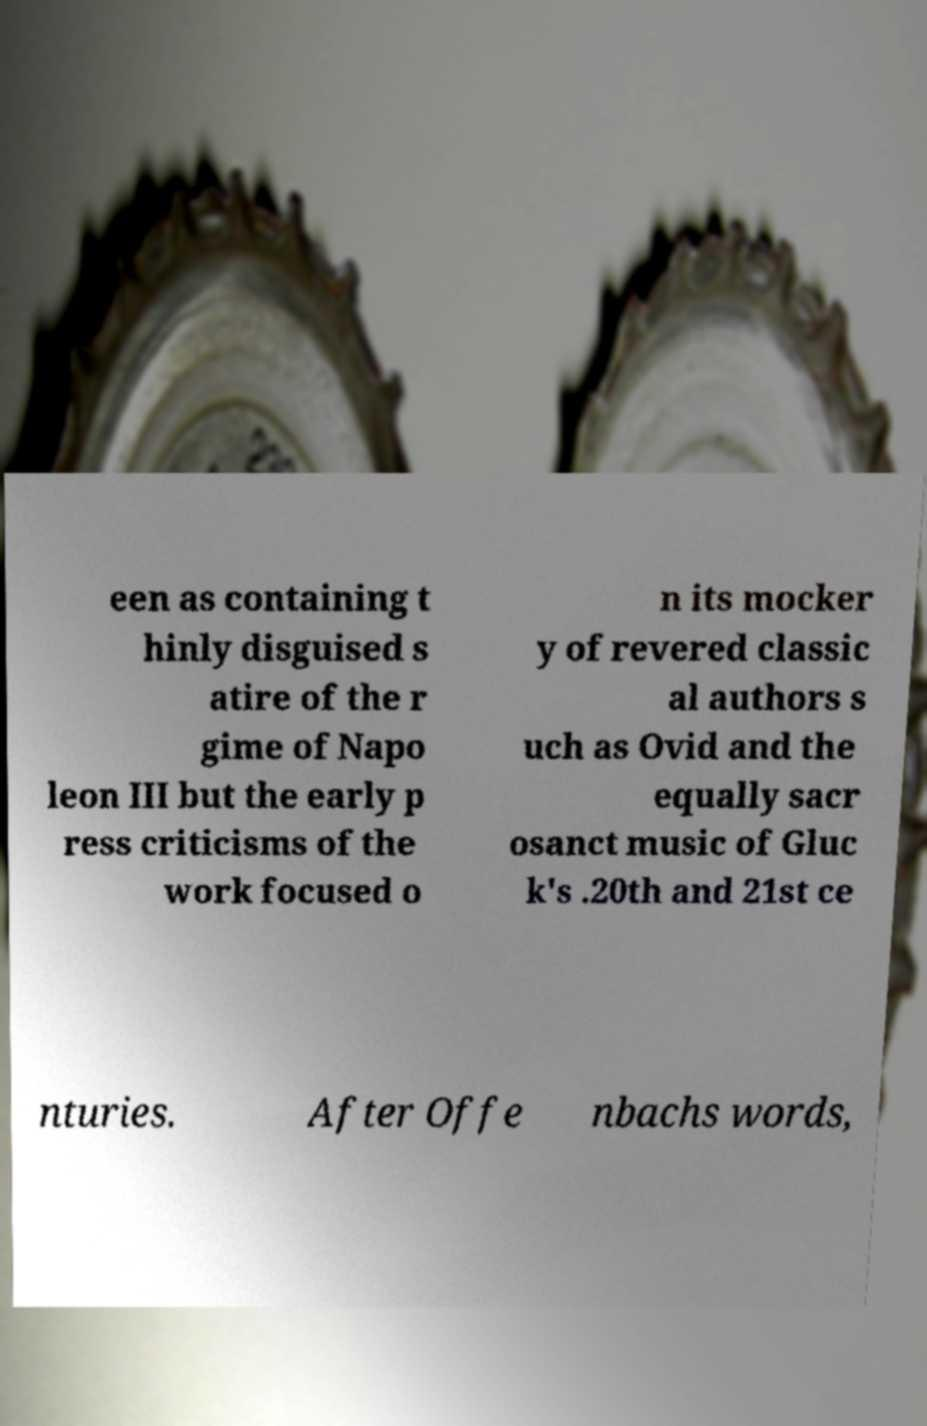There's text embedded in this image that I need extracted. Can you transcribe it verbatim? een as containing t hinly disguised s atire of the r gime of Napo leon III but the early p ress criticisms of the work focused o n its mocker y of revered classic al authors s uch as Ovid and the equally sacr osanct music of Gluc k's .20th and 21st ce nturies. After Offe nbachs words, 